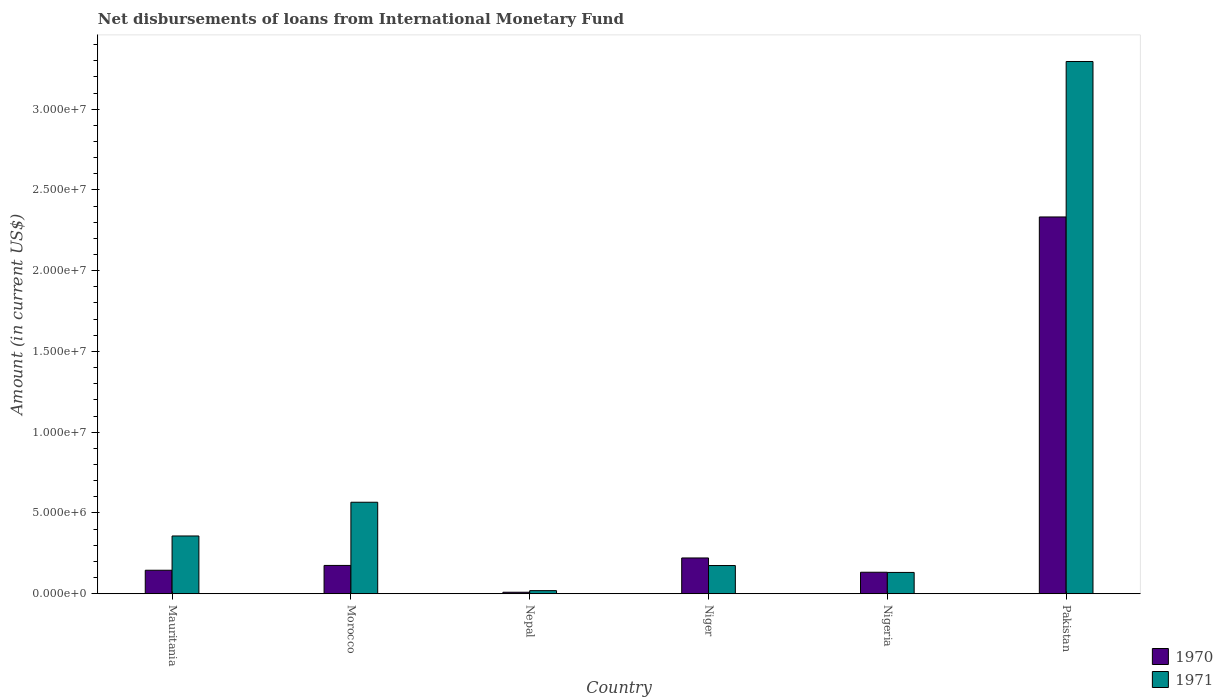Are the number of bars per tick equal to the number of legend labels?
Offer a very short reply. Yes. How many bars are there on the 1st tick from the right?
Your answer should be very brief. 2. What is the label of the 1st group of bars from the left?
Make the answer very short. Mauritania. In how many cases, is the number of bars for a given country not equal to the number of legend labels?
Give a very brief answer. 0. What is the amount of loans disbursed in 1970 in Morocco?
Provide a succinct answer. 1.75e+06. Across all countries, what is the maximum amount of loans disbursed in 1970?
Make the answer very short. 2.33e+07. Across all countries, what is the minimum amount of loans disbursed in 1970?
Your answer should be compact. 9.30e+04. In which country was the amount of loans disbursed in 1971 maximum?
Offer a terse response. Pakistan. In which country was the amount of loans disbursed in 1970 minimum?
Ensure brevity in your answer.  Nepal. What is the total amount of loans disbursed in 1971 in the graph?
Ensure brevity in your answer.  4.55e+07. What is the difference between the amount of loans disbursed in 1970 in Morocco and that in Niger?
Make the answer very short. -4.62e+05. What is the difference between the amount of loans disbursed in 1971 in Nepal and the amount of loans disbursed in 1970 in Nigeria?
Your response must be concise. -1.14e+06. What is the average amount of loans disbursed in 1971 per country?
Offer a terse response. 7.58e+06. What is the difference between the amount of loans disbursed of/in 1971 and amount of loans disbursed of/in 1970 in Nigeria?
Make the answer very short. -1.10e+04. What is the ratio of the amount of loans disbursed in 1970 in Niger to that in Pakistan?
Provide a short and direct response. 0.09. Is the amount of loans disbursed in 1971 in Morocco less than that in Nepal?
Ensure brevity in your answer.  No. Is the difference between the amount of loans disbursed in 1971 in Morocco and Pakistan greater than the difference between the amount of loans disbursed in 1970 in Morocco and Pakistan?
Give a very brief answer. No. What is the difference between the highest and the second highest amount of loans disbursed in 1971?
Provide a short and direct response. 2.73e+07. What is the difference between the highest and the lowest amount of loans disbursed in 1970?
Make the answer very short. 2.32e+07. Is the sum of the amount of loans disbursed in 1971 in Mauritania and Morocco greater than the maximum amount of loans disbursed in 1970 across all countries?
Make the answer very short. No. What does the 1st bar from the left in Pakistan represents?
Ensure brevity in your answer.  1970. What does the 1st bar from the right in Morocco represents?
Provide a short and direct response. 1971. How many bars are there?
Provide a succinct answer. 12. Are all the bars in the graph horizontal?
Provide a short and direct response. No. How many countries are there in the graph?
Keep it short and to the point. 6. Are the values on the major ticks of Y-axis written in scientific E-notation?
Your answer should be compact. Yes. Does the graph contain any zero values?
Give a very brief answer. No. Does the graph contain grids?
Your answer should be very brief. No. What is the title of the graph?
Offer a terse response. Net disbursements of loans from International Monetary Fund. Does "1978" appear as one of the legend labels in the graph?
Give a very brief answer. No. What is the Amount (in current US$) in 1970 in Mauritania?
Provide a short and direct response. 1.46e+06. What is the Amount (in current US$) of 1971 in Mauritania?
Keep it short and to the point. 3.58e+06. What is the Amount (in current US$) in 1970 in Morocco?
Your answer should be compact. 1.75e+06. What is the Amount (in current US$) in 1971 in Morocco?
Offer a very short reply. 5.66e+06. What is the Amount (in current US$) in 1970 in Nepal?
Your response must be concise. 9.30e+04. What is the Amount (in current US$) in 1971 in Nepal?
Ensure brevity in your answer.  1.93e+05. What is the Amount (in current US$) of 1970 in Niger?
Keep it short and to the point. 2.22e+06. What is the Amount (in current US$) of 1971 in Niger?
Ensure brevity in your answer.  1.75e+06. What is the Amount (in current US$) of 1970 in Nigeria?
Offer a very short reply. 1.33e+06. What is the Amount (in current US$) in 1971 in Nigeria?
Offer a very short reply. 1.32e+06. What is the Amount (in current US$) of 1970 in Pakistan?
Offer a terse response. 2.33e+07. What is the Amount (in current US$) in 1971 in Pakistan?
Keep it short and to the point. 3.30e+07. Across all countries, what is the maximum Amount (in current US$) of 1970?
Offer a very short reply. 2.33e+07. Across all countries, what is the maximum Amount (in current US$) of 1971?
Make the answer very short. 3.30e+07. Across all countries, what is the minimum Amount (in current US$) of 1970?
Provide a short and direct response. 9.30e+04. Across all countries, what is the minimum Amount (in current US$) of 1971?
Give a very brief answer. 1.93e+05. What is the total Amount (in current US$) of 1970 in the graph?
Your answer should be compact. 3.02e+07. What is the total Amount (in current US$) of 1971 in the graph?
Provide a short and direct response. 4.55e+07. What is the difference between the Amount (in current US$) in 1970 in Mauritania and that in Morocco?
Offer a very short reply. -2.98e+05. What is the difference between the Amount (in current US$) of 1971 in Mauritania and that in Morocco?
Your answer should be very brief. -2.09e+06. What is the difference between the Amount (in current US$) of 1970 in Mauritania and that in Nepal?
Your answer should be very brief. 1.36e+06. What is the difference between the Amount (in current US$) of 1971 in Mauritania and that in Nepal?
Provide a succinct answer. 3.38e+06. What is the difference between the Amount (in current US$) in 1970 in Mauritania and that in Niger?
Offer a very short reply. -7.60e+05. What is the difference between the Amount (in current US$) in 1971 in Mauritania and that in Niger?
Keep it short and to the point. 1.83e+06. What is the difference between the Amount (in current US$) of 1970 in Mauritania and that in Nigeria?
Offer a very short reply. 1.24e+05. What is the difference between the Amount (in current US$) in 1971 in Mauritania and that in Nigeria?
Keep it short and to the point. 2.26e+06. What is the difference between the Amount (in current US$) in 1970 in Mauritania and that in Pakistan?
Keep it short and to the point. -2.19e+07. What is the difference between the Amount (in current US$) in 1971 in Mauritania and that in Pakistan?
Offer a very short reply. -2.94e+07. What is the difference between the Amount (in current US$) in 1970 in Morocco and that in Nepal?
Offer a very short reply. 1.66e+06. What is the difference between the Amount (in current US$) in 1971 in Morocco and that in Nepal?
Offer a very short reply. 5.47e+06. What is the difference between the Amount (in current US$) of 1970 in Morocco and that in Niger?
Give a very brief answer. -4.62e+05. What is the difference between the Amount (in current US$) in 1971 in Morocco and that in Niger?
Give a very brief answer. 3.92e+06. What is the difference between the Amount (in current US$) of 1970 in Morocco and that in Nigeria?
Offer a terse response. 4.22e+05. What is the difference between the Amount (in current US$) in 1971 in Morocco and that in Nigeria?
Offer a very short reply. 4.34e+06. What is the difference between the Amount (in current US$) of 1970 in Morocco and that in Pakistan?
Your answer should be very brief. -2.16e+07. What is the difference between the Amount (in current US$) of 1971 in Morocco and that in Pakistan?
Provide a short and direct response. -2.73e+07. What is the difference between the Amount (in current US$) of 1970 in Nepal and that in Niger?
Offer a very short reply. -2.12e+06. What is the difference between the Amount (in current US$) of 1971 in Nepal and that in Niger?
Give a very brief answer. -1.55e+06. What is the difference between the Amount (in current US$) of 1970 in Nepal and that in Nigeria?
Give a very brief answer. -1.24e+06. What is the difference between the Amount (in current US$) in 1971 in Nepal and that in Nigeria?
Provide a short and direct response. -1.13e+06. What is the difference between the Amount (in current US$) in 1970 in Nepal and that in Pakistan?
Your answer should be very brief. -2.32e+07. What is the difference between the Amount (in current US$) in 1971 in Nepal and that in Pakistan?
Provide a succinct answer. -3.28e+07. What is the difference between the Amount (in current US$) of 1970 in Niger and that in Nigeria?
Your answer should be very brief. 8.84e+05. What is the difference between the Amount (in current US$) in 1971 in Niger and that in Nigeria?
Your answer should be compact. 4.26e+05. What is the difference between the Amount (in current US$) in 1970 in Niger and that in Pakistan?
Offer a very short reply. -2.11e+07. What is the difference between the Amount (in current US$) of 1971 in Niger and that in Pakistan?
Make the answer very short. -3.12e+07. What is the difference between the Amount (in current US$) in 1970 in Nigeria and that in Pakistan?
Your answer should be very brief. -2.20e+07. What is the difference between the Amount (in current US$) in 1971 in Nigeria and that in Pakistan?
Ensure brevity in your answer.  -3.16e+07. What is the difference between the Amount (in current US$) in 1970 in Mauritania and the Amount (in current US$) in 1971 in Morocco?
Your answer should be very brief. -4.21e+06. What is the difference between the Amount (in current US$) in 1970 in Mauritania and the Amount (in current US$) in 1971 in Nepal?
Your answer should be compact. 1.26e+06. What is the difference between the Amount (in current US$) of 1970 in Mauritania and the Amount (in current US$) of 1971 in Niger?
Offer a very short reply. -2.91e+05. What is the difference between the Amount (in current US$) in 1970 in Mauritania and the Amount (in current US$) in 1971 in Nigeria?
Your answer should be very brief. 1.35e+05. What is the difference between the Amount (in current US$) in 1970 in Mauritania and the Amount (in current US$) in 1971 in Pakistan?
Your answer should be very brief. -3.15e+07. What is the difference between the Amount (in current US$) of 1970 in Morocco and the Amount (in current US$) of 1971 in Nepal?
Your response must be concise. 1.56e+06. What is the difference between the Amount (in current US$) of 1970 in Morocco and the Amount (in current US$) of 1971 in Niger?
Provide a succinct answer. 7000. What is the difference between the Amount (in current US$) of 1970 in Morocco and the Amount (in current US$) of 1971 in Nigeria?
Your answer should be compact. 4.33e+05. What is the difference between the Amount (in current US$) in 1970 in Morocco and the Amount (in current US$) in 1971 in Pakistan?
Your answer should be very brief. -3.12e+07. What is the difference between the Amount (in current US$) in 1970 in Nepal and the Amount (in current US$) in 1971 in Niger?
Offer a very short reply. -1.65e+06. What is the difference between the Amount (in current US$) of 1970 in Nepal and the Amount (in current US$) of 1971 in Nigeria?
Provide a short and direct response. -1.23e+06. What is the difference between the Amount (in current US$) in 1970 in Nepal and the Amount (in current US$) in 1971 in Pakistan?
Offer a very short reply. -3.29e+07. What is the difference between the Amount (in current US$) in 1970 in Niger and the Amount (in current US$) in 1971 in Nigeria?
Make the answer very short. 8.95e+05. What is the difference between the Amount (in current US$) of 1970 in Niger and the Amount (in current US$) of 1971 in Pakistan?
Provide a succinct answer. -3.07e+07. What is the difference between the Amount (in current US$) of 1970 in Nigeria and the Amount (in current US$) of 1971 in Pakistan?
Ensure brevity in your answer.  -3.16e+07. What is the average Amount (in current US$) of 1970 per country?
Your answer should be compact. 5.03e+06. What is the average Amount (in current US$) of 1971 per country?
Provide a short and direct response. 7.58e+06. What is the difference between the Amount (in current US$) of 1970 and Amount (in current US$) of 1971 in Mauritania?
Give a very brief answer. -2.12e+06. What is the difference between the Amount (in current US$) in 1970 and Amount (in current US$) in 1971 in Morocco?
Give a very brief answer. -3.91e+06. What is the difference between the Amount (in current US$) in 1970 and Amount (in current US$) in 1971 in Nepal?
Your response must be concise. -1.00e+05. What is the difference between the Amount (in current US$) in 1970 and Amount (in current US$) in 1971 in Niger?
Provide a succinct answer. 4.69e+05. What is the difference between the Amount (in current US$) in 1970 and Amount (in current US$) in 1971 in Nigeria?
Your answer should be compact. 1.10e+04. What is the difference between the Amount (in current US$) in 1970 and Amount (in current US$) in 1971 in Pakistan?
Offer a very short reply. -9.62e+06. What is the ratio of the Amount (in current US$) of 1970 in Mauritania to that in Morocco?
Your response must be concise. 0.83. What is the ratio of the Amount (in current US$) of 1971 in Mauritania to that in Morocco?
Provide a succinct answer. 0.63. What is the ratio of the Amount (in current US$) of 1970 in Mauritania to that in Nepal?
Offer a terse response. 15.65. What is the ratio of the Amount (in current US$) in 1971 in Mauritania to that in Nepal?
Keep it short and to the point. 18.53. What is the ratio of the Amount (in current US$) in 1970 in Mauritania to that in Niger?
Ensure brevity in your answer.  0.66. What is the ratio of the Amount (in current US$) of 1971 in Mauritania to that in Niger?
Offer a terse response. 2.05. What is the ratio of the Amount (in current US$) of 1970 in Mauritania to that in Nigeria?
Offer a terse response. 1.09. What is the ratio of the Amount (in current US$) of 1971 in Mauritania to that in Nigeria?
Give a very brief answer. 2.71. What is the ratio of the Amount (in current US$) in 1970 in Mauritania to that in Pakistan?
Offer a very short reply. 0.06. What is the ratio of the Amount (in current US$) in 1971 in Mauritania to that in Pakistan?
Provide a short and direct response. 0.11. What is the ratio of the Amount (in current US$) in 1970 in Morocco to that in Nepal?
Give a very brief answer. 18.85. What is the ratio of the Amount (in current US$) in 1971 in Morocco to that in Nepal?
Your answer should be compact. 29.35. What is the ratio of the Amount (in current US$) in 1970 in Morocco to that in Niger?
Keep it short and to the point. 0.79. What is the ratio of the Amount (in current US$) in 1971 in Morocco to that in Niger?
Make the answer very short. 3.24. What is the ratio of the Amount (in current US$) of 1970 in Morocco to that in Nigeria?
Give a very brief answer. 1.32. What is the ratio of the Amount (in current US$) in 1971 in Morocco to that in Nigeria?
Give a very brief answer. 4.29. What is the ratio of the Amount (in current US$) in 1970 in Morocco to that in Pakistan?
Provide a short and direct response. 0.08. What is the ratio of the Amount (in current US$) of 1971 in Morocco to that in Pakistan?
Give a very brief answer. 0.17. What is the ratio of the Amount (in current US$) in 1970 in Nepal to that in Niger?
Provide a short and direct response. 0.04. What is the ratio of the Amount (in current US$) of 1971 in Nepal to that in Niger?
Keep it short and to the point. 0.11. What is the ratio of the Amount (in current US$) in 1970 in Nepal to that in Nigeria?
Offer a very short reply. 0.07. What is the ratio of the Amount (in current US$) in 1971 in Nepal to that in Nigeria?
Offer a terse response. 0.15. What is the ratio of the Amount (in current US$) of 1970 in Nepal to that in Pakistan?
Ensure brevity in your answer.  0. What is the ratio of the Amount (in current US$) in 1971 in Nepal to that in Pakistan?
Your answer should be compact. 0.01. What is the ratio of the Amount (in current US$) in 1970 in Niger to that in Nigeria?
Offer a very short reply. 1.66. What is the ratio of the Amount (in current US$) in 1971 in Niger to that in Nigeria?
Make the answer very short. 1.32. What is the ratio of the Amount (in current US$) in 1970 in Niger to that in Pakistan?
Make the answer very short. 0.1. What is the ratio of the Amount (in current US$) in 1971 in Niger to that in Pakistan?
Your answer should be compact. 0.05. What is the ratio of the Amount (in current US$) of 1970 in Nigeria to that in Pakistan?
Your answer should be very brief. 0.06. What is the ratio of the Amount (in current US$) of 1971 in Nigeria to that in Pakistan?
Your answer should be compact. 0.04. What is the difference between the highest and the second highest Amount (in current US$) in 1970?
Give a very brief answer. 2.11e+07. What is the difference between the highest and the second highest Amount (in current US$) of 1971?
Ensure brevity in your answer.  2.73e+07. What is the difference between the highest and the lowest Amount (in current US$) in 1970?
Your answer should be compact. 2.32e+07. What is the difference between the highest and the lowest Amount (in current US$) of 1971?
Provide a short and direct response. 3.28e+07. 